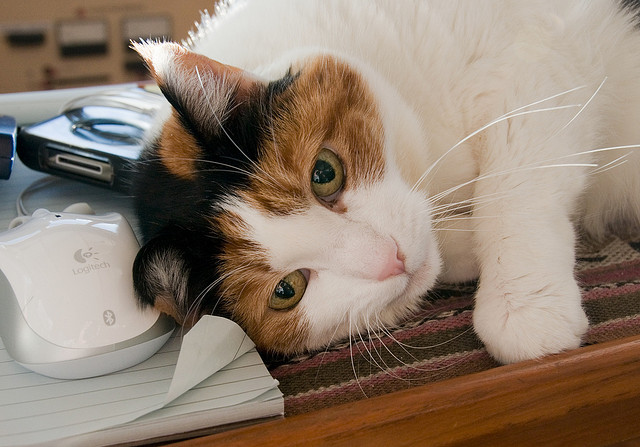Identify and read out the text in this image. Logitech 